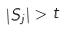Convert formula to latex. <formula><loc_0><loc_0><loc_500><loc_500>| S _ { j } | > t</formula> 